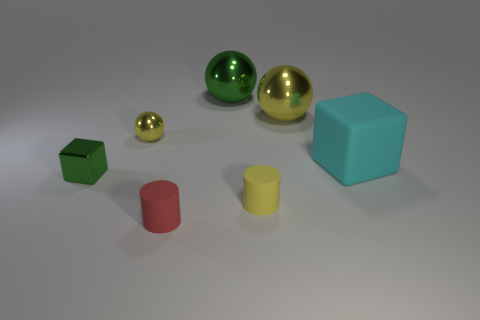Are these objects arranged in a specific pattern or order? While there doesn't seem to be a strict pattern, the objects are laid out in a balanced way, with varying shapes and colors creating a visually pleasing assortment. 